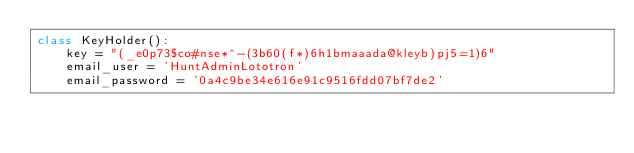Convert code to text. <code><loc_0><loc_0><loc_500><loc_500><_Python_>class KeyHolder():
    key = "(_e0p73$co#nse*^-(3b60(f*)6h1bmaaada@kleyb)pj5=1)6"
    email_user = 'HuntAdminLototron'
    email_password = '0a4c9be34e616e91c9516fdd07bf7de2'


</code> 